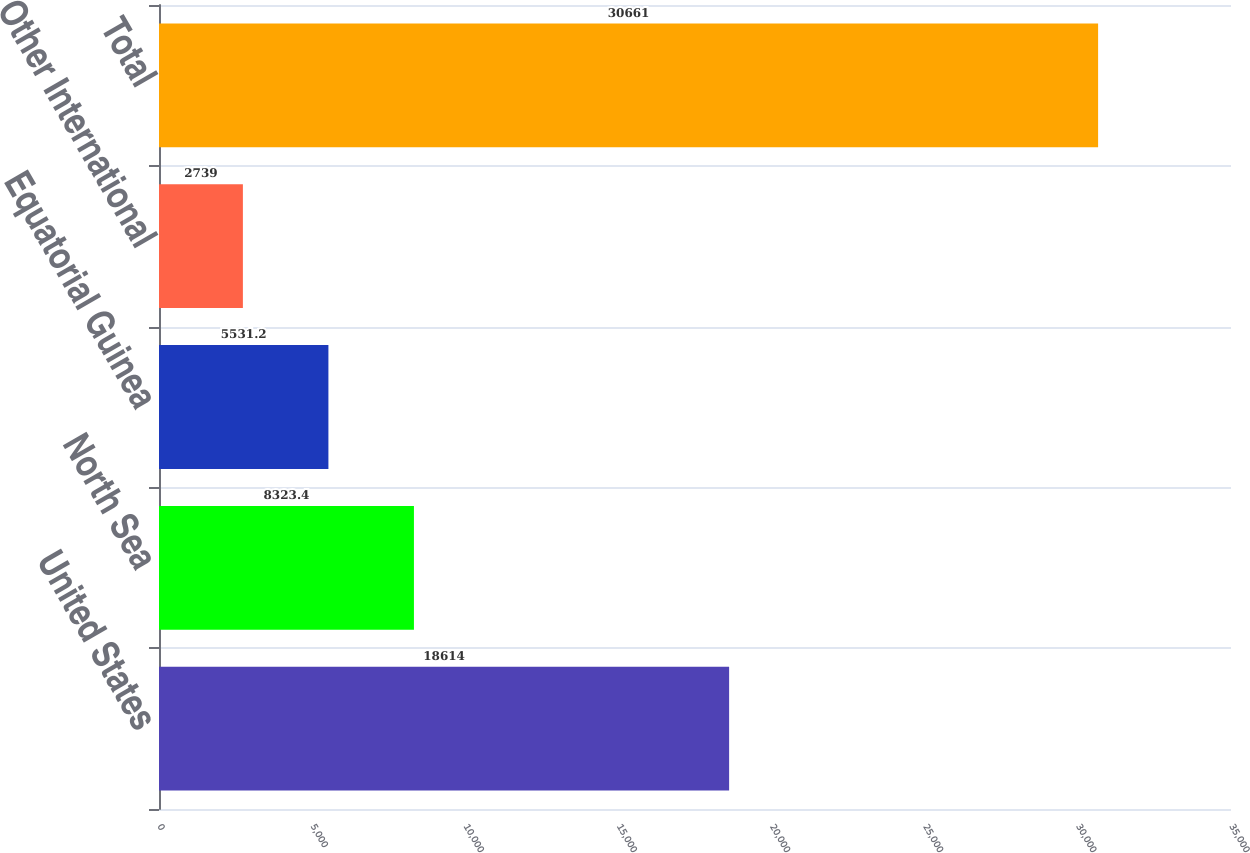<chart> <loc_0><loc_0><loc_500><loc_500><bar_chart><fcel>United States<fcel>North Sea<fcel>Equatorial Guinea<fcel>Other International<fcel>Total<nl><fcel>18614<fcel>8323.4<fcel>5531.2<fcel>2739<fcel>30661<nl></chart> 